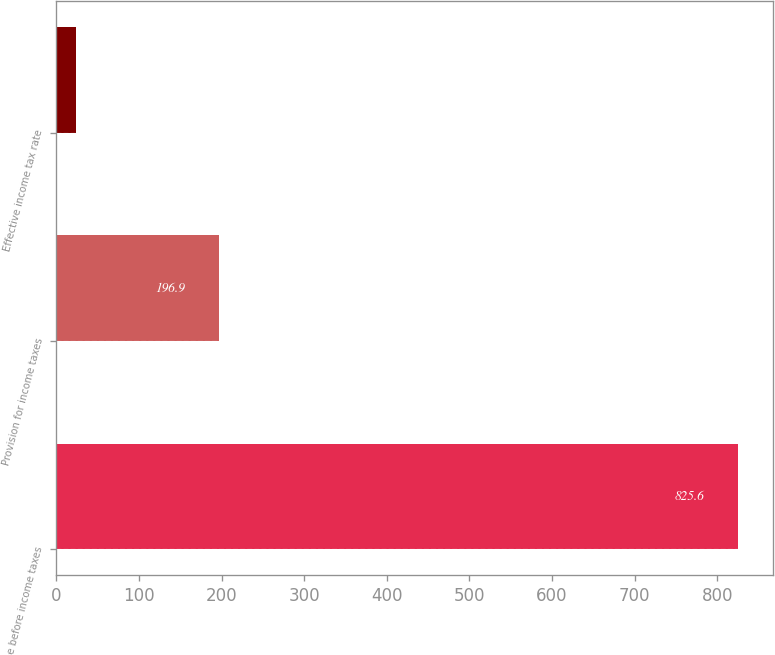Convert chart. <chart><loc_0><loc_0><loc_500><loc_500><bar_chart><fcel>Income before income taxes<fcel>Provision for income taxes<fcel>Effective income tax rate<nl><fcel>825.6<fcel>196.9<fcel>23.8<nl></chart> 